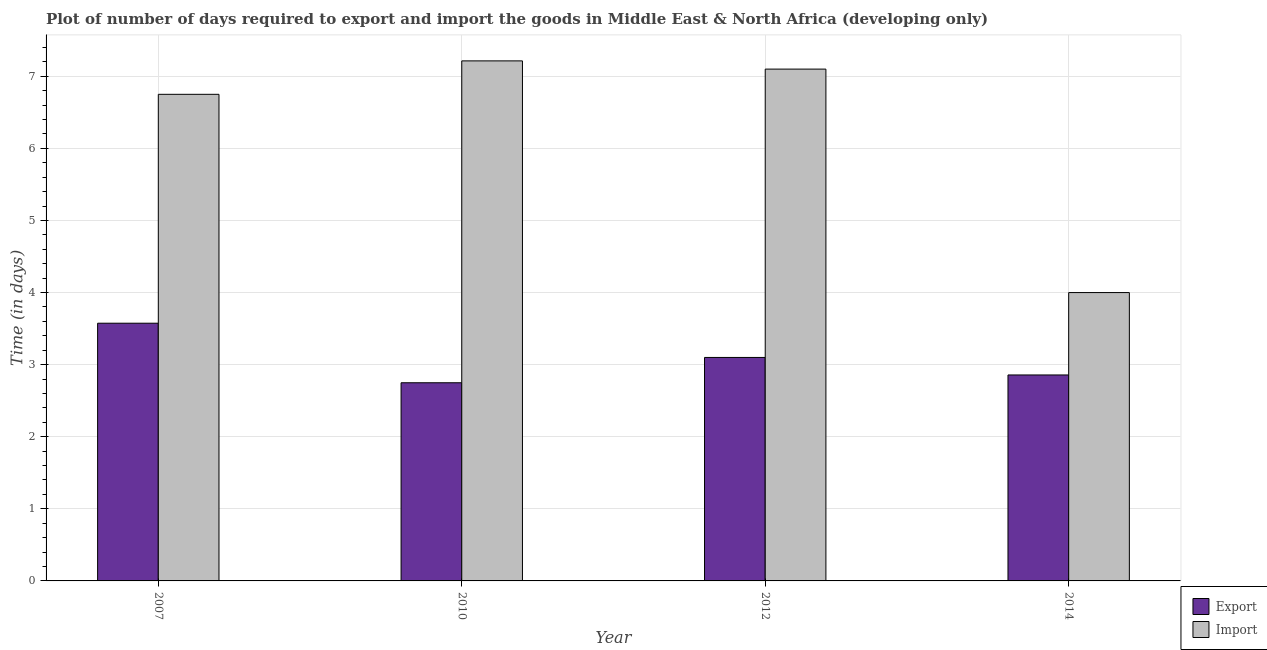How many bars are there on the 3rd tick from the left?
Make the answer very short. 2. What is the time required to import in 2012?
Give a very brief answer. 7.1. Across all years, what is the maximum time required to export?
Provide a succinct answer. 3.58. Across all years, what is the minimum time required to import?
Provide a succinct answer. 4. In which year was the time required to export maximum?
Provide a short and direct response. 2007. In which year was the time required to export minimum?
Offer a terse response. 2010. What is the total time required to export in the graph?
Make the answer very short. 12.28. What is the difference between the time required to import in 2012 and that in 2014?
Provide a short and direct response. 3.1. What is the difference between the time required to import in 2012 and the time required to export in 2010?
Your response must be concise. -0.11. What is the average time required to import per year?
Provide a succinct answer. 6.27. In how many years, is the time required to import greater than 2.8 days?
Offer a terse response. 4. What is the ratio of the time required to export in 2007 to that in 2010?
Keep it short and to the point. 1.3. What is the difference between the highest and the second highest time required to import?
Offer a very short reply. 0.11. What is the difference between the highest and the lowest time required to export?
Offer a terse response. 0.83. What does the 2nd bar from the left in 2012 represents?
Offer a terse response. Import. What does the 2nd bar from the right in 2014 represents?
Your answer should be compact. Export. How many bars are there?
Ensure brevity in your answer.  8. Are all the bars in the graph horizontal?
Keep it short and to the point. No. What is the difference between two consecutive major ticks on the Y-axis?
Give a very brief answer. 1. How are the legend labels stacked?
Make the answer very short. Vertical. What is the title of the graph?
Your response must be concise. Plot of number of days required to export and import the goods in Middle East & North Africa (developing only). Does "Electricity and heat production" appear as one of the legend labels in the graph?
Ensure brevity in your answer.  No. What is the label or title of the Y-axis?
Your answer should be compact. Time (in days). What is the Time (in days) of Export in 2007?
Ensure brevity in your answer.  3.58. What is the Time (in days) of Import in 2007?
Give a very brief answer. 6.75. What is the Time (in days) in Export in 2010?
Ensure brevity in your answer.  2.75. What is the Time (in days) in Import in 2010?
Provide a short and direct response. 7.21. What is the Time (in days) of Import in 2012?
Offer a very short reply. 7.1. What is the Time (in days) of Export in 2014?
Ensure brevity in your answer.  2.86. Across all years, what is the maximum Time (in days) of Export?
Give a very brief answer. 3.58. Across all years, what is the maximum Time (in days) in Import?
Your answer should be compact. 7.21. Across all years, what is the minimum Time (in days) in Export?
Ensure brevity in your answer.  2.75. Across all years, what is the minimum Time (in days) in Import?
Your answer should be very brief. 4. What is the total Time (in days) of Export in the graph?
Ensure brevity in your answer.  12.28. What is the total Time (in days) of Import in the graph?
Your answer should be very brief. 25.06. What is the difference between the Time (in days) of Export in 2007 and that in 2010?
Give a very brief answer. 0.83. What is the difference between the Time (in days) in Import in 2007 and that in 2010?
Give a very brief answer. -0.46. What is the difference between the Time (in days) in Export in 2007 and that in 2012?
Your answer should be compact. 0.47. What is the difference between the Time (in days) of Import in 2007 and that in 2012?
Make the answer very short. -0.35. What is the difference between the Time (in days) in Export in 2007 and that in 2014?
Offer a very short reply. 0.72. What is the difference between the Time (in days) in Import in 2007 and that in 2014?
Provide a short and direct response. 2.75. What is the difference between the Time (in days) of Export in 2010 and that in 2012?
Your answer should be compact. -0.35. What is the difference between the Time (in days) of Import in 2010 and that in 2012?
Provide a succinct answer. 0.11. What is the difference between the Time (in days) in Export in 2010 and that in 2014?
Provide a succinct answer. -0.11. What is the difference between the Time (in days) in Import in 2010 and that in 2014?
Your answer should be very brief. 3.21. What is the difference between the Time (in days) of Export in 2012 and that in 2014?
Offer a terse response. 0.24. What is the difference between the Time (in days) of Import in 2012 and that in 2014?
Offer a terse response. 3.1. What is the difference between the Time (in days) in Export in 2007 and the Time (in days) in Import in 2010?
Your answer should be compact. -3.64. What is the difference between the Time (in days) of Export in 2007 and the Time (in days) of Import in 2012?
Make the answer very short. -3.52. What is the difference between the Time (in days) in Export in 2007 and the Time (in days) in Import in 2014?
Provide a succinct answer. -0.42. What is the difference between the Time (in days) in Export in 2010 and the Time (in days) in Import in 2012?
Provide a succinct answer. -4.35. What is the difference between the Time (in days) of Export in 2010 and the Time (in days) of Import in 2014?
Offer a very short reply. -1.25. What is the difference between the Time (in days) in Export in 2012 and the Time (in days) in Import in 2014?
Your answer should be very brief. -0.9. What is the average Time (in days) of Export per year?
Your answer should be compact. 3.07. What is the average Time (in days) in Import per year?
Make the answer very short. 6.27. In the year 2007, what is the difference between the Time (in days) of Export and Time (in days) of Import?
Ensure brevity in your answer.  -3.17. In the year 2010, what is the difference between the Time (in days) in Export and Time (in days) in Import?
Offer a very short reply. -4.46. In the year 2014, what is the difference between the Time (in days) in Export and Time (in days) in Import?
Provide a succinct answer. -1.14. What is the ratio of the Time (in days) in Export in 2007 to that in 2010?
Your answer should be very brief. 1.3. What is the ratio of the Time (in days) in Import in 2007 to that in 2010?
Provide a short and direct response. 0.94. What is the ratio of the Time (in days) in Export in 2007 to that in 2012?
Provide a short and direct response. 1.15. What is the ratio of the Time (in days) of Import in 2007 to that in 2012?
Your answer should be very brief. 0.95. What is the ratio of the Time (in days) of Export in 2007 to that in 2014?
Offer a terse response. 1.25. What is the ratio of the Time (in days) in Import in 2007 to that in 2014?
Offer a very short reply. 1.69. What is the ratio of the Time (in days) in Export in 2010 to that in 2012?
Keep it short and to the point. 0.89. What is the ratio of the Time (in days) in Import in 2010 to that in 2012?
Keep it short and to the point. 1.02. What is the ratio of the Time (in days) in Export in 2010 to that in 2014?
Your response must be concise. 0.96. What is the ratio of the Time (in days) in Import in 2010 to that in 2014?
Ensure brevity in your answer.  1.8. What is the ratio of the Time (in days) in Export in 2012 to that in 2014?
Your response must be concise. 1.08. What is the ratio of the Time (in days) in Import in 2012 to that in 2014?
Ensure brevity in your answer.  1.77. What is the difference between the highest and the second highest Time (in days) in Export?
Give a very brief answer. 0.47. What is the difference between the highest and the second highest Time (in days) of Import?
Give a very brief answer. 0.11. What is the difference between the highest and the lowest Time (in days) in Export?
Offer a very short reply. 0.83. What is the difference between the highest and the lowest Time (in days) in Import?
Ensure brevity in your answer.  3.21. 